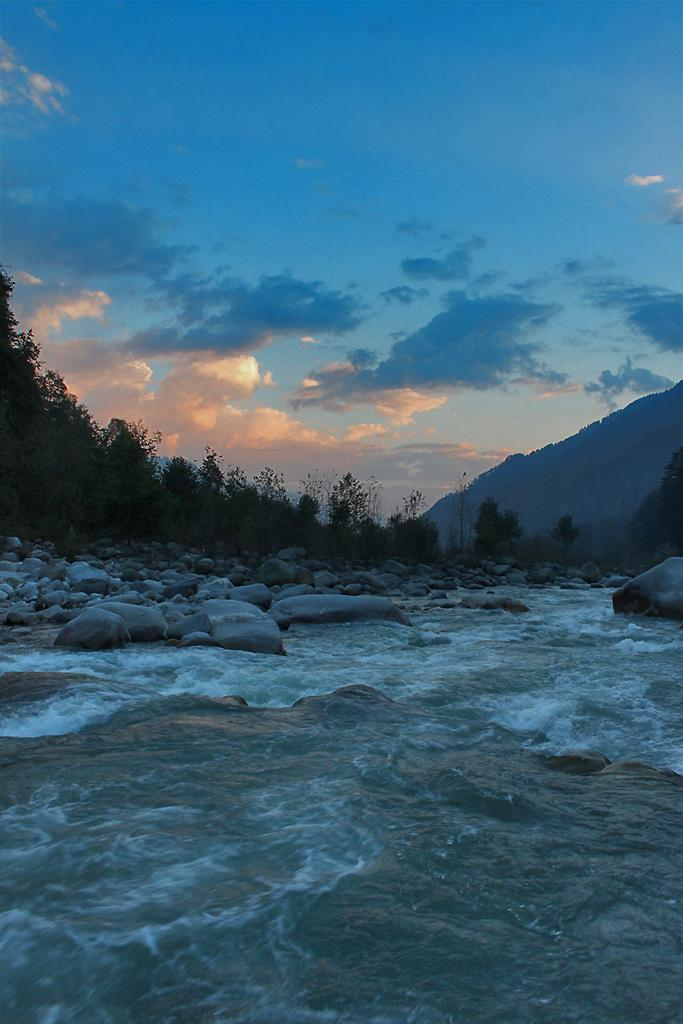What is the main element in the image? There is water in the image. What other objects or features can be seen in the image? Stones, trees, and a hill are visible in the image. How would you describe the sky in the image? The sky is blue and cloudy. How many balloons are floating in the water in the image? There are no balloons present in the image. Is there a fire visible in the image? There is no fire visible in the image. 